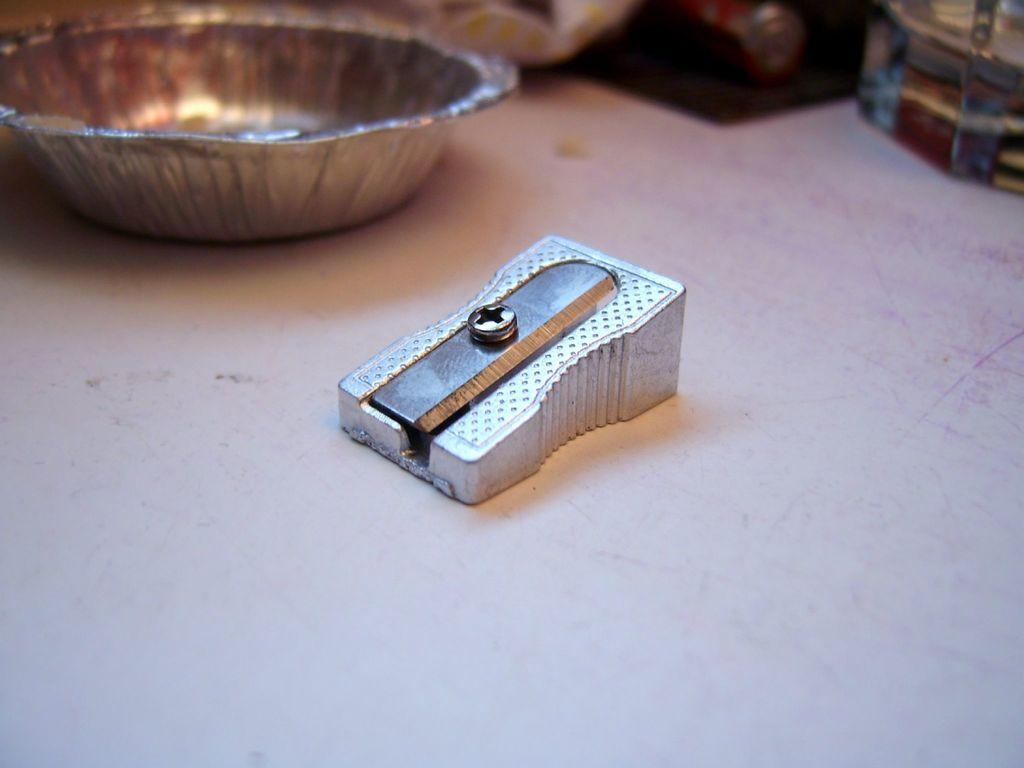What object is located in the middle of the image? There is a pencil sharpener in the middle of the image. What can be seen in the background of the image? There is a cup in the background of the image. How many clams are visible in the image? There are no clams present in the image. What type of battle is taking place in the image? There is no battle depicted in the image; it features a pencil sharpener and a cup in the background. 